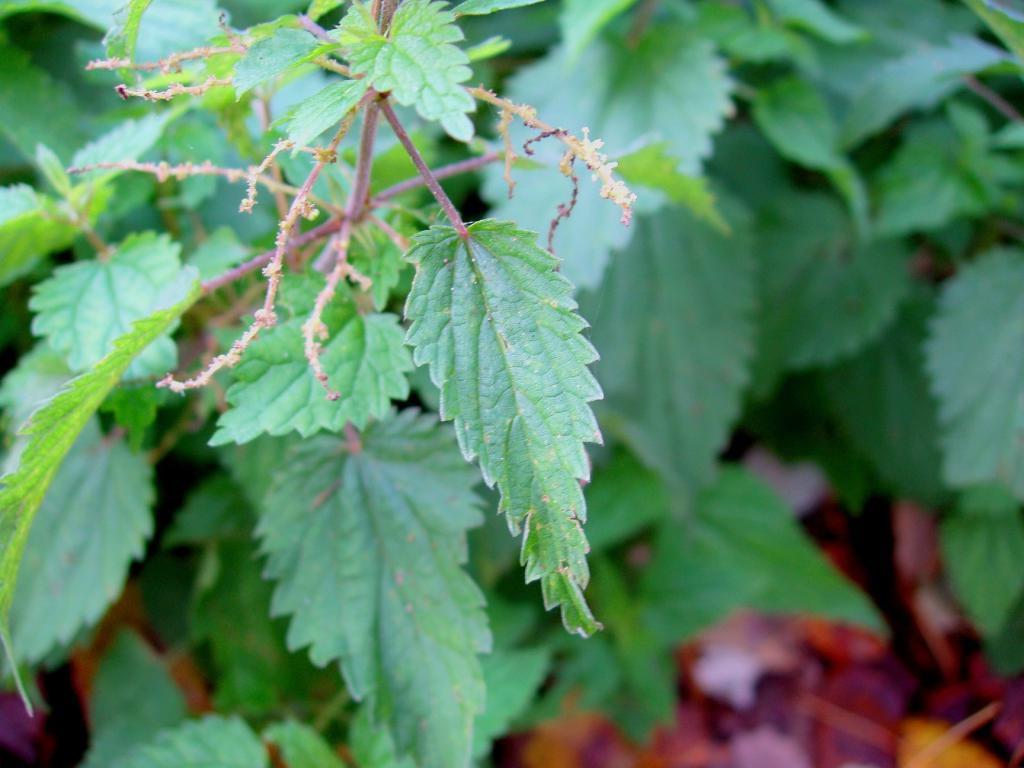In one or two sentences, can you explain what this image depicts? In this image there are leaves. 